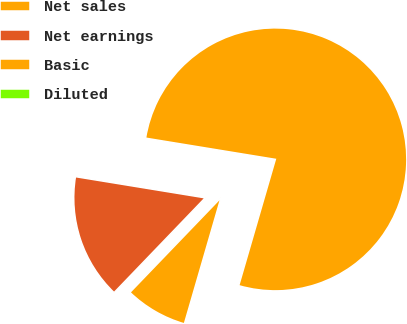<chart> <loc_0><loc_0><loc_500><loc_500><pie_chart><fcel>Net sales<fcel>Net earnings<fcel>Basic<fcel>Diluted<nl><fcel>76.92%<fcel>15.39%<fcel>7.69%<fcel>0.0%<nl></chart> 